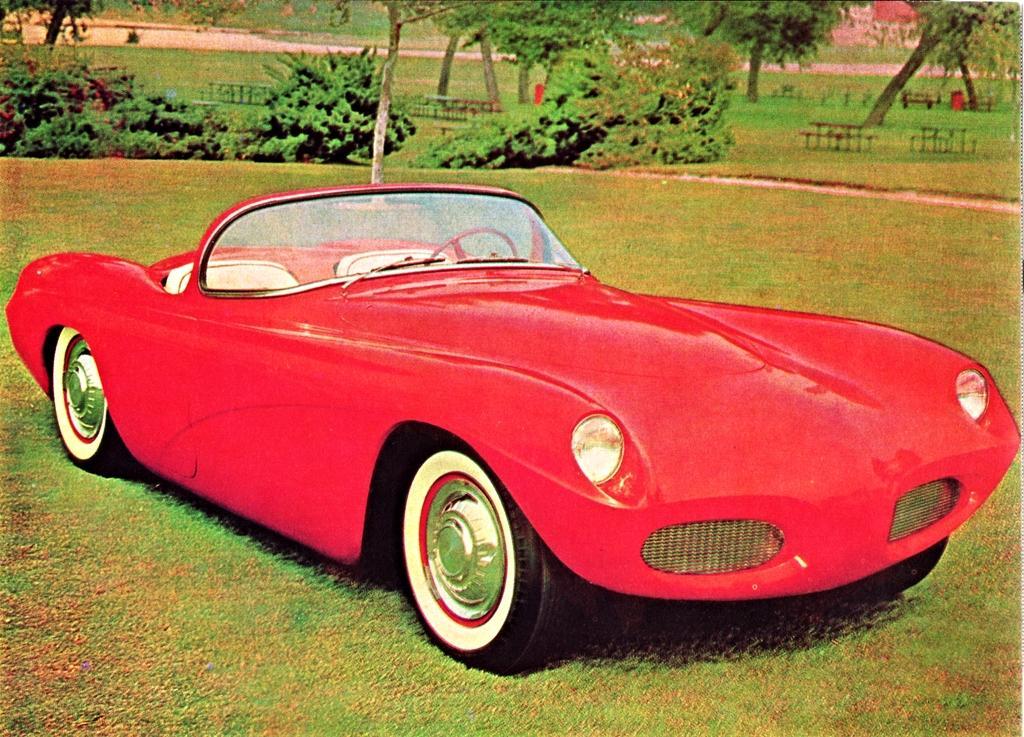Can you describe this image briefly? In the image there is a red car on the grassland and behind there are plants and trees. 